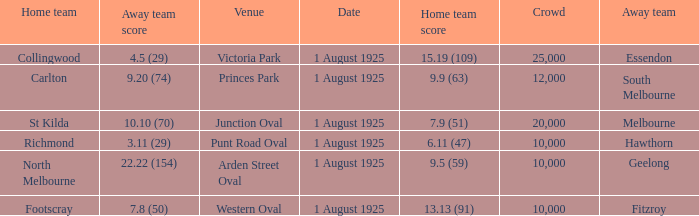Which match where Hawthorn was the away team had the largest crowd? 10000.0. 